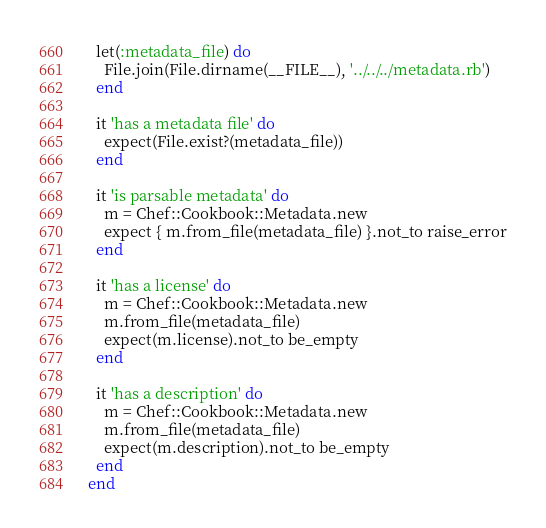<code> <loc_0><loc_0><loc_500><loc_500><_Ruby_>  let(:metadata_file) do
    File.join(File.dirname(__FILE__), '../../../metadata.rb')
  end

  it 'has a metadata file' do
    expect(File.exist?(metadata_file))
  end

  it 'is parsable metadata' do
    m = Chef::Cookbook::Metadata.new
    expect { m.from_file(metadata_file) }.not_to raise_error
  end

  it 'has a license' do
    m = Chef::Cookbook::Metadata.new
    m.from_file(metadata_file)
    expect(m.license).not_to be_empty
  end

  it 'has a description' do
    m = Chef::Cookbook::Metadata.new
    m.from_file(metadata_file)
    expect(m.description).not_to be_empty
  end
end
</code> 